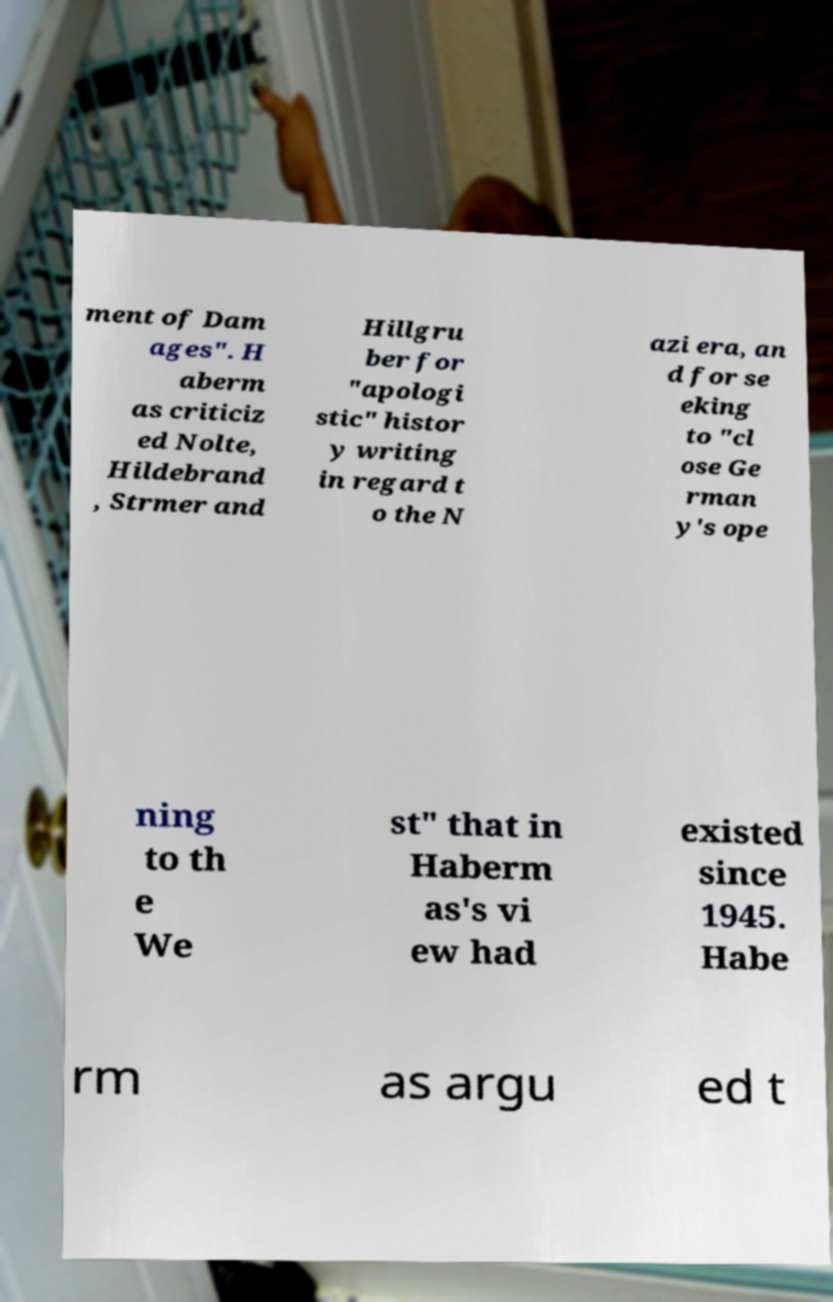Please identify and transcribe the text found in this image. ment of Dam ages". H aberm as criticiz ed Nolte, Hildebrand , Strmer and Hillgru ber for "apologi stic" histor y writing in regard t o the N azi era, an d for se eking to "cl ose Ge rman y's ope ning to th e We st" that in Haberm as's vi ew had existed since 1945. Habe rm as argu ed t 